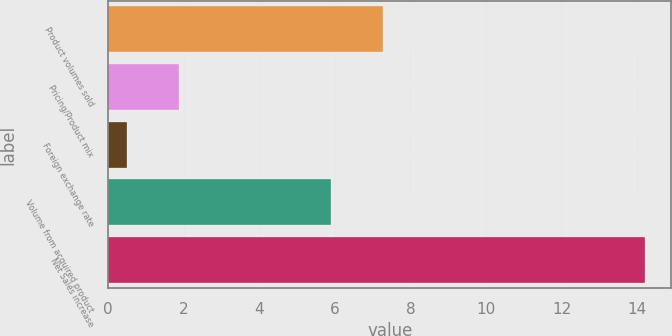<chart> <loc_0><loc_0><loc_500><loc_500><bar_chart><fcel>Product volumes sold<fcel>Pricing/Product mix<fcel>Foreign exchange rate<fcel>Volume from acquired product<fcel>Net Sales increase<nl><fcel>7.27<fcel>1.87<fcel>0.5<fcel>5.9<fcel>14.2<nl></chart> 